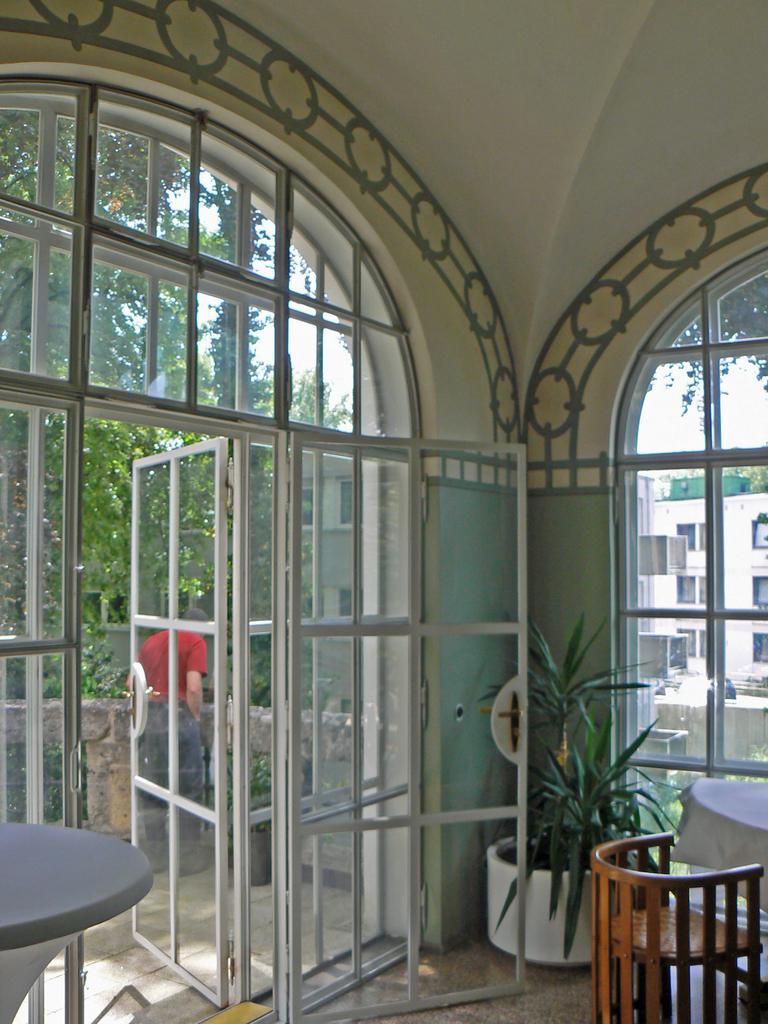Please provide a concise description of this image. In this image there is the sky, there are buildings towards the right of the image, there are windows, there are trees towards the left of the image, there is a man standing, there is an inside view of a room, there is a door, there is a glass wall, there is a table towards the left of the image, there is a table towards the right of the image, there is a cloth on the table, there is a cloth on the table, there is a chair towards the right of the image, there is floor towards the bottom of the image, there is a flower pot on the floor, there is a plant. 